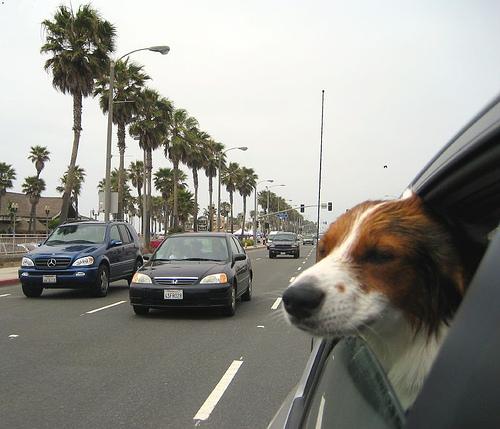What season is it?
Quick response, please. Summer. What is the dog looking at?
Answer briefly. Cars. What color is one of the cars?
Give a very brief answer. Blue. Where is the dog?
Keep it brief. Car. 